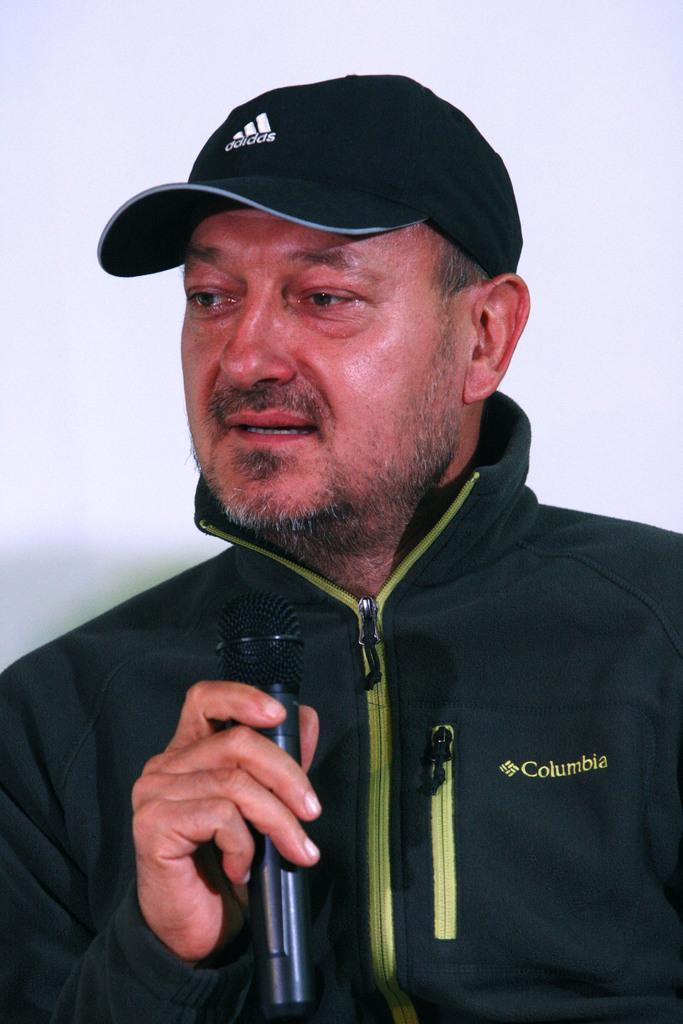How would you summarize this image in a sentence or two? In the picture I can see a man is holding a microphone in the hand. The man is wearing a jacket and black color cap. The background of the image is white in color. 